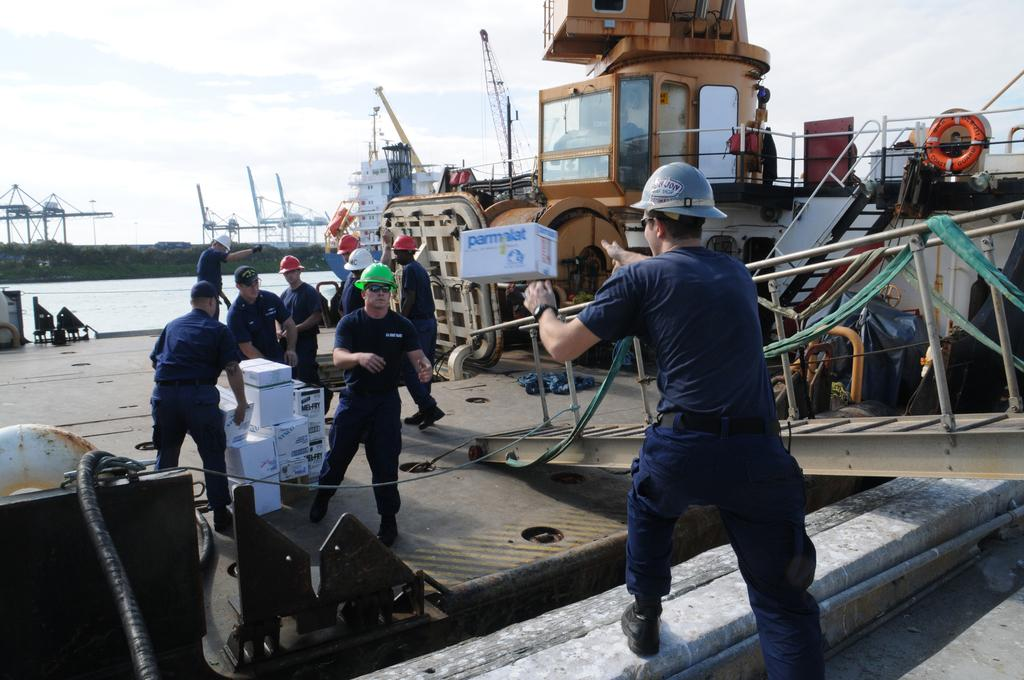What type of vehicles are at the deck in the image? There are ships at the deck in the image. What are the men in the image doing? The men are standing on the floor in the image. What type of containers are visible in the image? Cardboard cartons are visible in the image. What natural element is present in the image? There is water visible in the image. What type of vegetation is present in the image? Trees are present in the image. What part of the natural environment is visible in the image? The sky is visible in the image, and clouds are present in the sky. What type of religious ceremony is taking place on the ships in the image? There is no indication of a religious ceremony in the image; it features ships, men, cardboard cartons, water, trees, and the sky. What is the best route to take to reach the ships in the image? The image does not provide information about the location or accessibility of the ships, so it is not possible to determine the best route. 